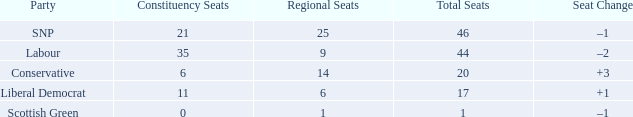How many regional seats were associated with the snp party when the overall seat count was greater than 46? 0.0. 